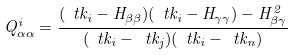<formula> <loc_0><loc_0><loc_500><loc_500>Q ^ { i } _ { \alpha \alpha } = \frac { ( \ t k _ { i } - H _ { \beta \beta } ) ( \ t k _ { i } - H _ { \gamma \gamma } ) - H ^ { 2 } _ { \beta \gamma } } { ( \ t k _ { i } - \ t k _ { j } ) ( \ t k _ { i } - \ t k _ { n } ) }</formula> 